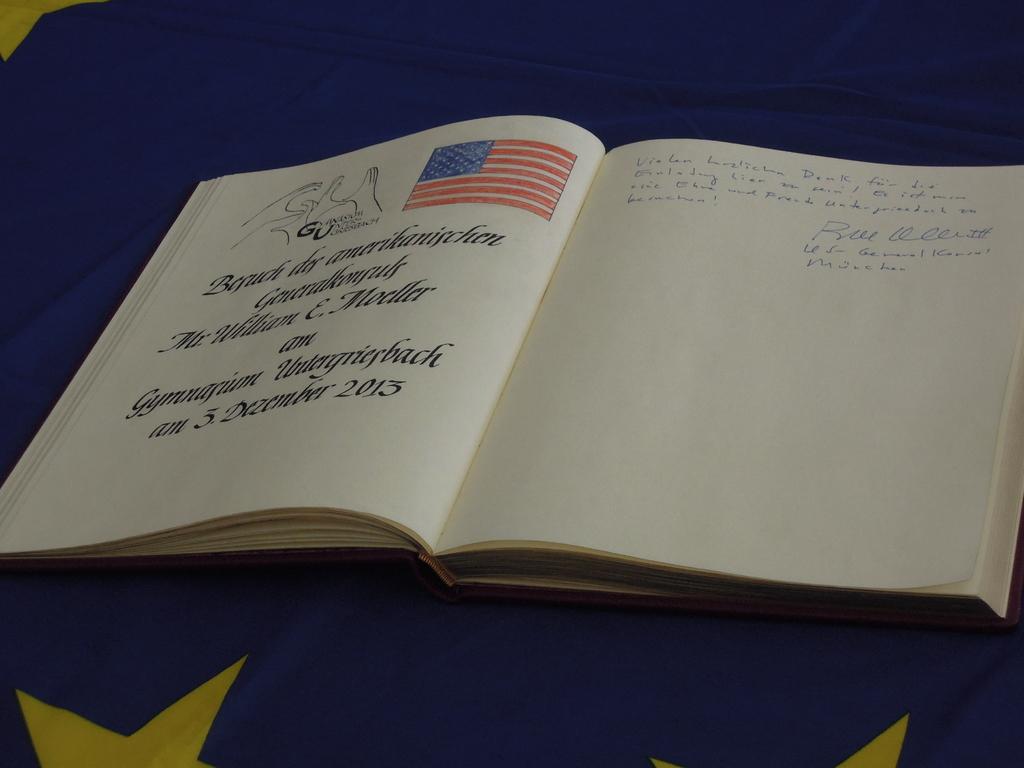What month was this signed on?
Your response must be concise. December. What year is the book?
Provide a succinct answer. 2013. 